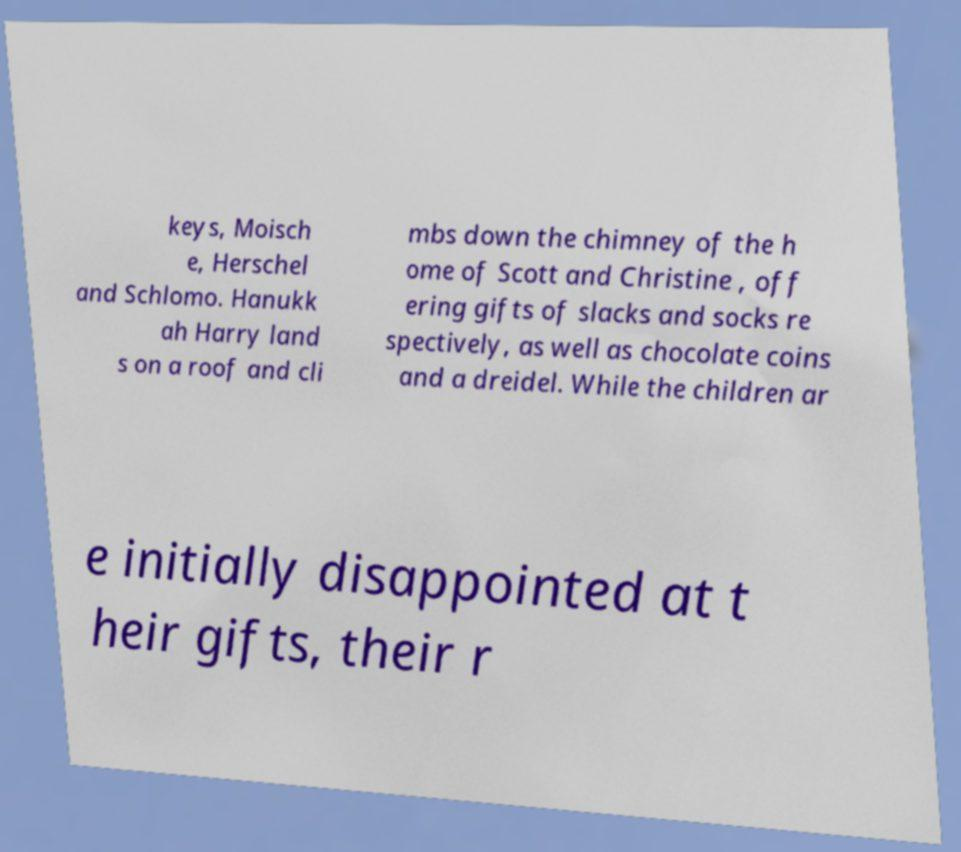Can you read and provide the text displayed in the image?This photo seems to have some interesting text. Can you extract and type it out for me? keys, Moisch e, Herschel and Schlomo. Hanukk ah Harry land s on a roof and cli mbs down the chimney of the h ome of Scott and Christine , off ering gifts of slacks and socks re spectively, as well as chocolate coins and a dreidel. While the children ar e initially disappointed at t heir gifts, their r 